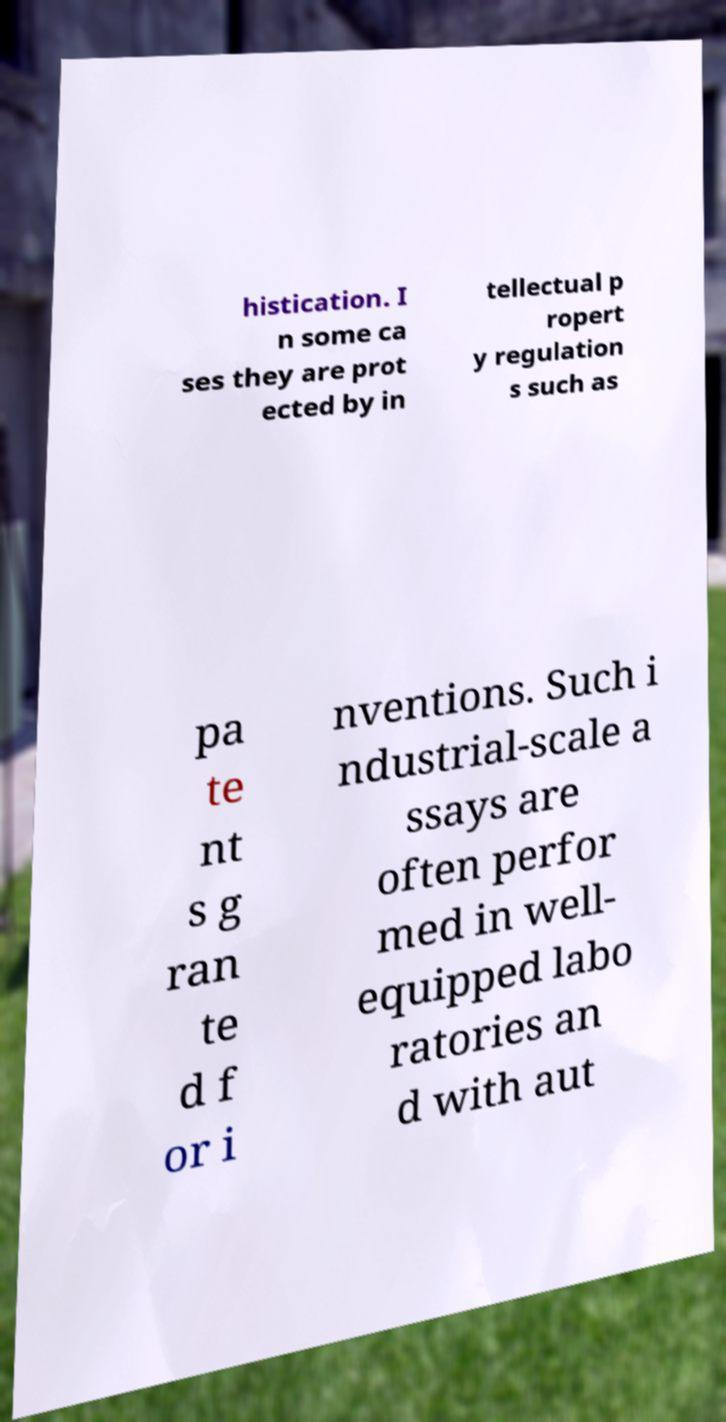Could you extract and type out the text from this image? histication. I n some ca ses they are prot ected by in tellectual p ropert y regulation s such as pa te nt s g ran te d f or i nventions. Such i ndustrial-scale a ssays are often perfor med in well- equipped labo ratories an d with aut 